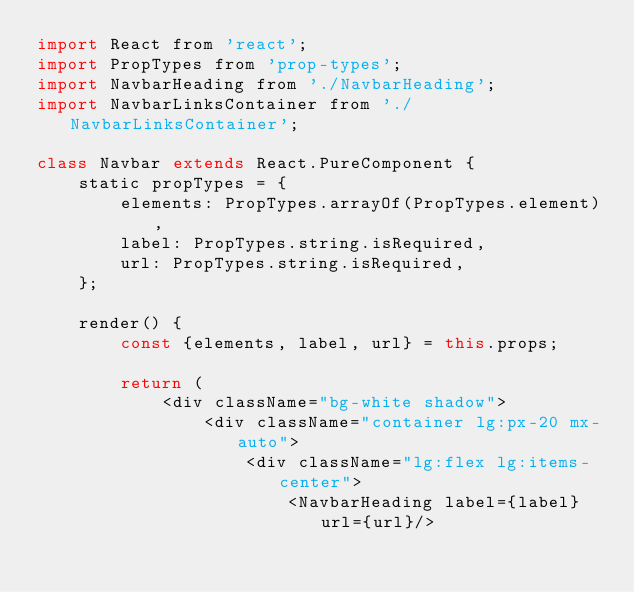Convert code to text. <code><loc_0><loc_0><loc_500><loc_500><_JavaScript_>import React from 'react';
import PropTypes from 'prop-types';
import NavbarHeading from './NavbarHeading';
import NavbarLinksContainer from './NavbarLinksContainer';

class Navbar extends React.PureComponent {
    static propTypes = {
        elements: PropTypes.arrayOf(PropTypes.element),
        label: PropTypes.string.isRequired,
        url: PropTypes.string.isRequired,
    };

    render() {
        const {elements, label, url} = this.props;

        return (
            <div className="bg-white shadow">
                <div className="container lg:px-20 mx-auto">
                    <div className="lg:flex lg:items-center">
                        <NavbarHeading label={label} url={url}/>
</code> 